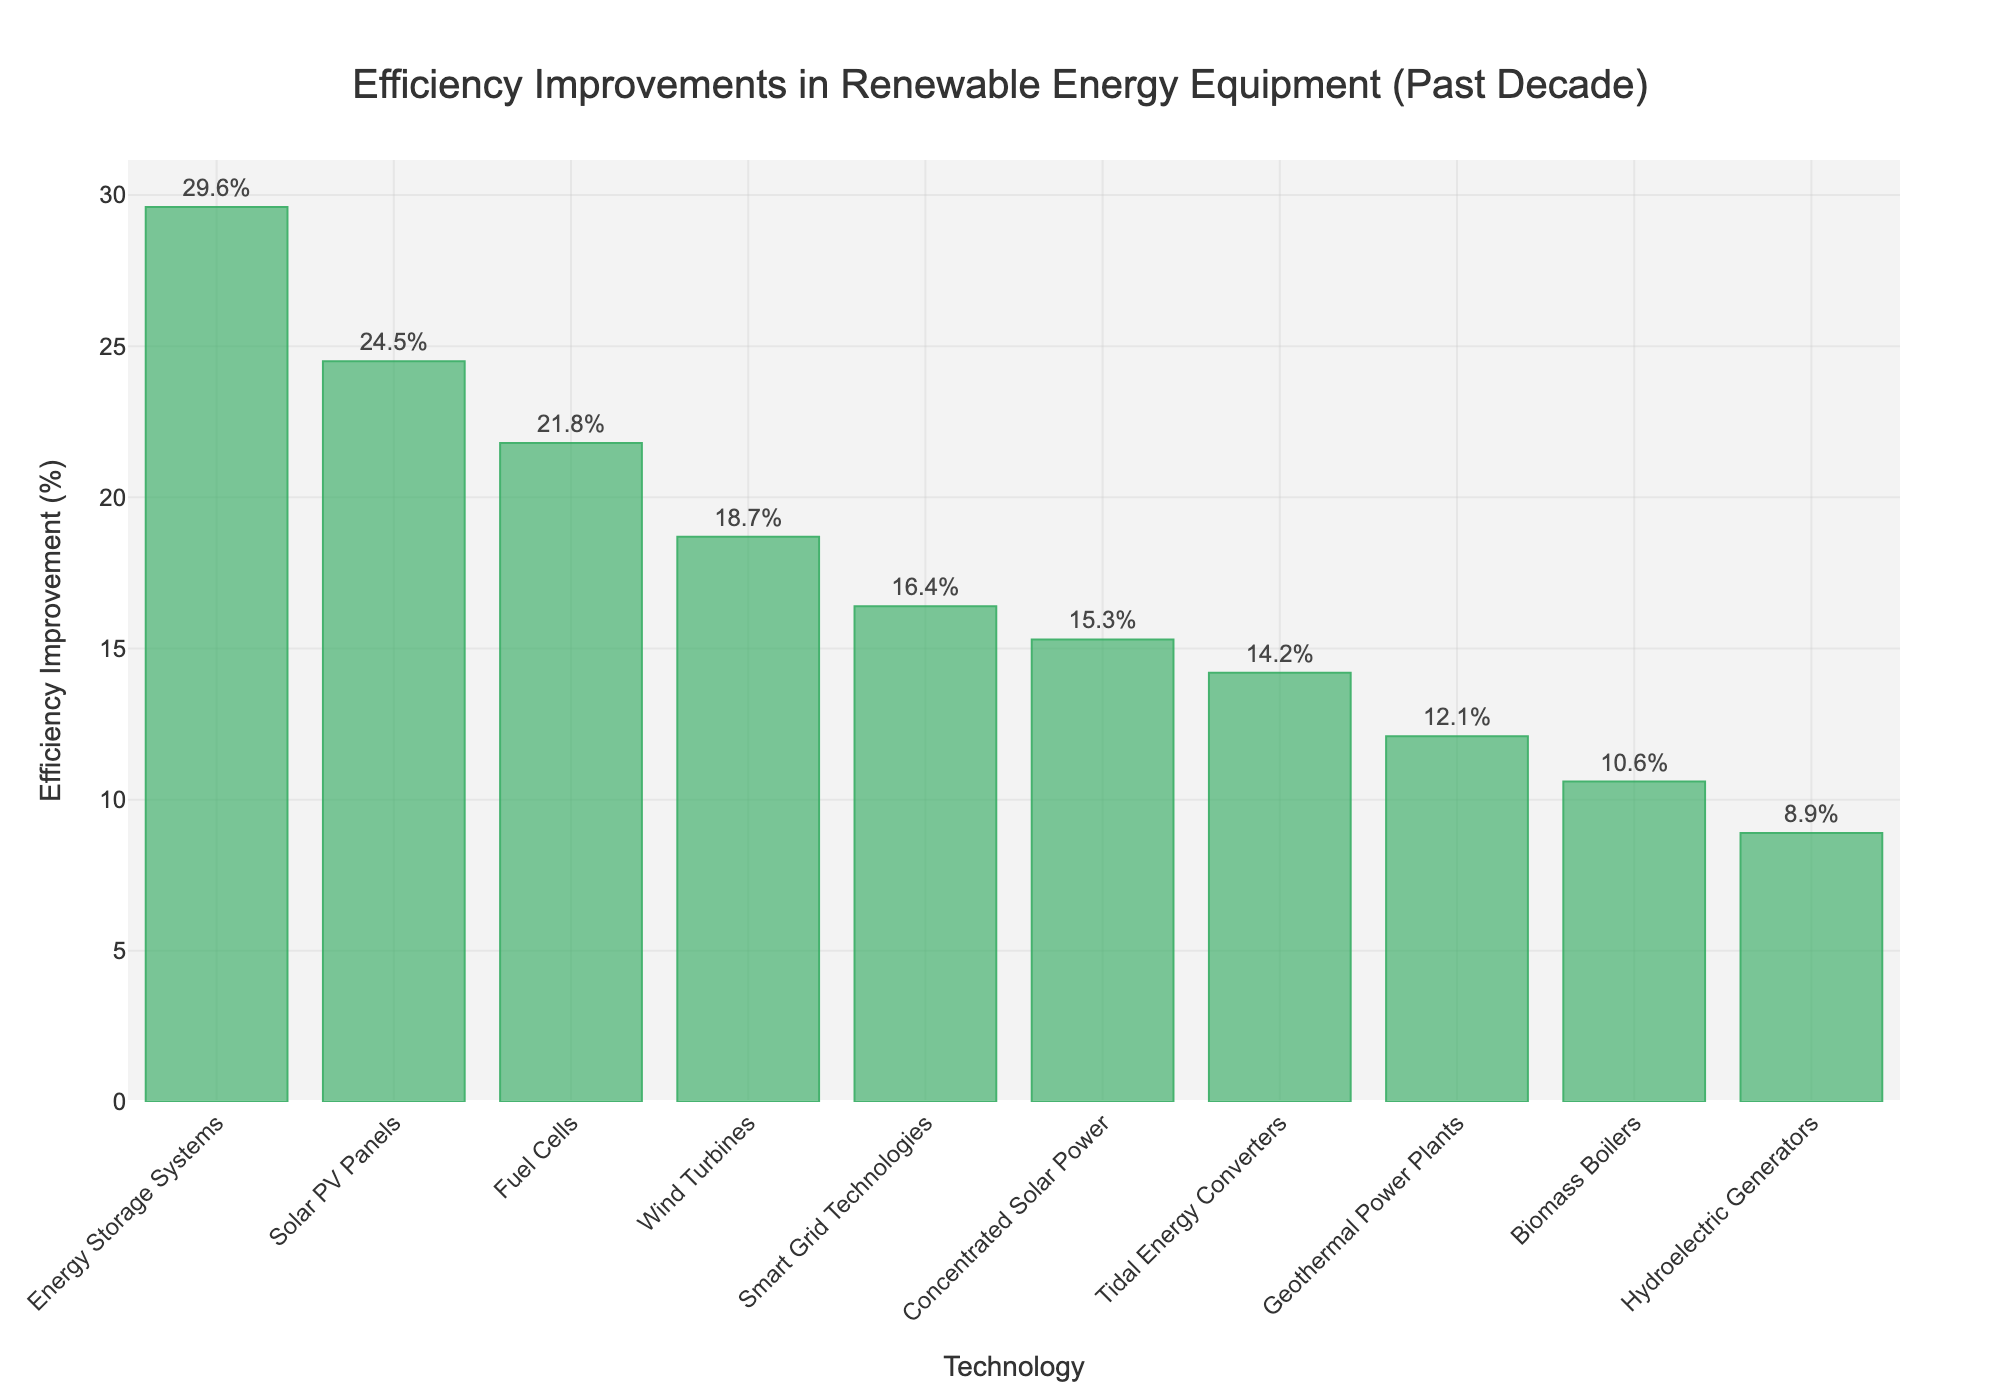What technology has the highest efficiency improvement percentage? From the chart, the bar for Energy Storage Systems is the tallest, indicating the highest efficiency improvement percentage.
Answer: Energy Storage Systems What is the difference in efficiency improvement percentage between the highest and lowest technology? The highest improvement is Energy Storage Systems at 29.6%, and the lowest is Hydroelectric Generators at 8.9%. Calculating the difference: 29.6 - 8.9.
Answer: 20.7% Which technologies have an efficiency improvement percentage greater than 20%? From the chart, three technologies surpass 20%: Solar PV Panels (24.5%), Energy Storage Systems (29.6%), and Fuel Cells (21.8%).
Answer: Solar PV Panels, Energy Storage Systems, Fuel Cells What is the average efficiency improvement percentage of Solar PV Panels, Wind Turbines, and Fuel Cells? Adding the percentages: 24.5 (Solar PV Panels) + 18.7 (Wind Turbines) + 21.8 (Fuel Cells) = 65. Dividing by the number of technologies (3): 65/3.
Answer: 21.67% How much is the efficiency improvement percentage of Tidal Energy Converters more than that of Biomass Boilers? Tidal Energy Converters' improvement is 14.2%, and Biomass Boilers' is 10.6%. Subtracting these values: 14.2 - 10.6.
Answer: 3.6% What is the sum of the efficiency improvement percentages of the least three efficient technologies? Adding the percentages for Hydroelectric Generators (8.9%), Geothermal Power Plants (12.1%), and Biomass Boilers (10.6%): 8.9 + 12.1 + 10.6.
Answer: 31.6% How many technologies have an efficiency improvement percentage below 15%? From the chart, four technologies: Hydroelectric Generators (8.9%), Geothermal Power Plants (12.1%), Biomass Boilers (10.6%), and Concentrated Solar Power (15.3%) *< 15*.
Answer: 3 Which technology is placed second in terms of efficiency improvement percentage? Observing the descending order of bars in the chart, Solar PV Panels have the highest, followed by Energy Storage Systems.
Answer: Energy Storage Systems Which two technologies have efficiency improvements closest to each other? Comparing the improvements, Smart Grid Technologies (16.4%) and Wind Turbines (18.7%) are the closest.
Answer: Smart Grid Technologies and Wind Turbines 